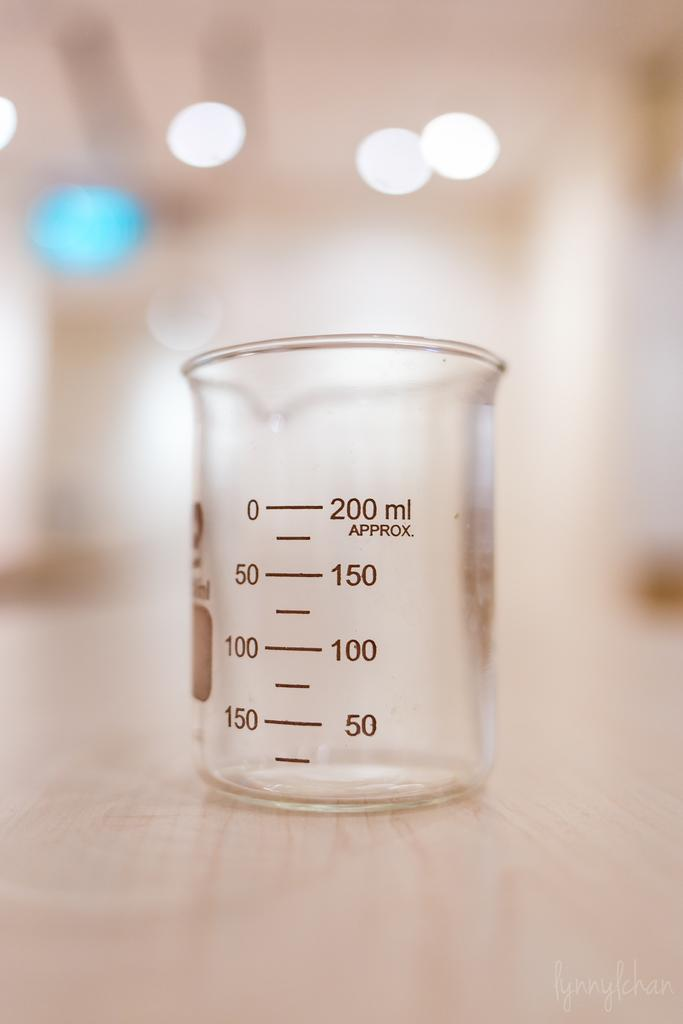<image>
Relay a brief, clear account of the picture shown. The measuring cup holds up to 200 ml of liquid. 